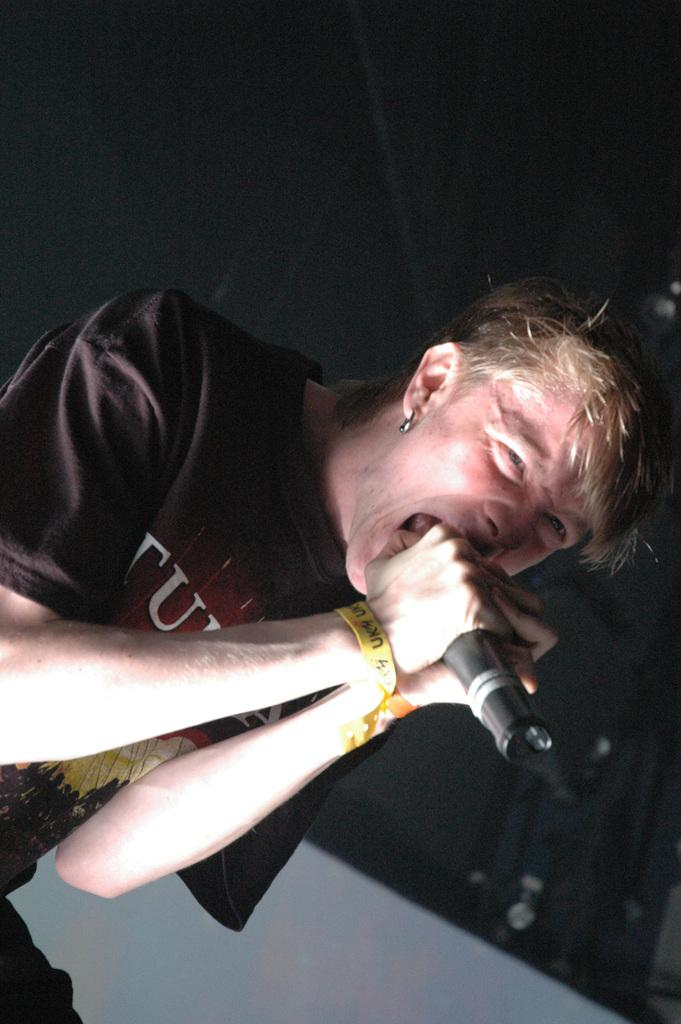What is the man in the image doing? The man is singing. What is the man holding in the image? The man is holding a mic. What colors can be seen in the background of the image? There is a black color sheet and a white color object in the background of the image. What type of meeting is taking place in the image? There is no meeting present in the image; it features a man singing with a mic. What color is the party decoration in the image? There is no party decoration present in the image. 